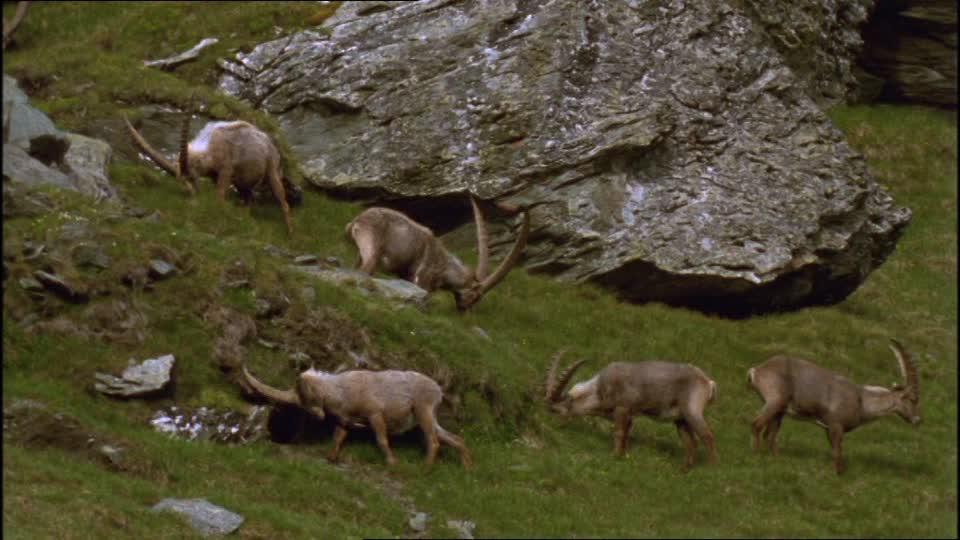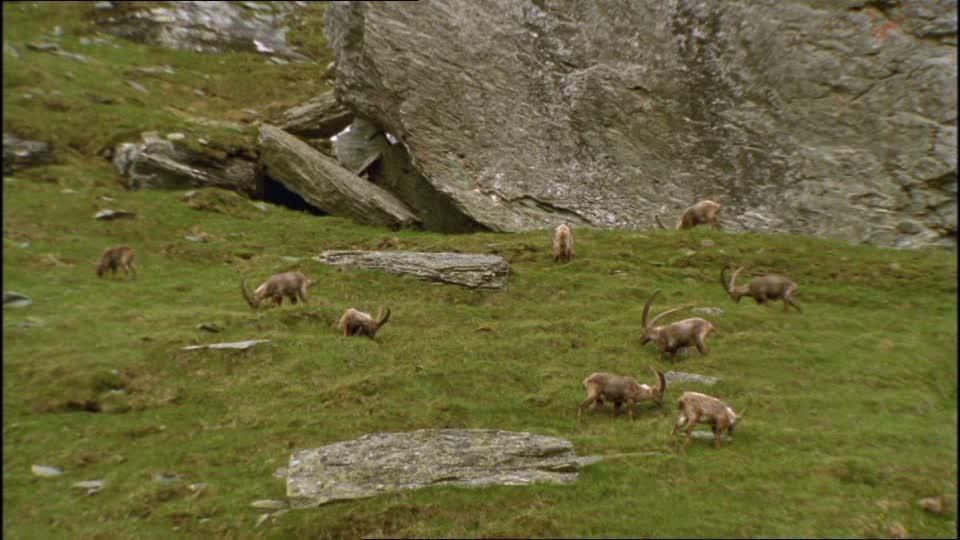The first image is the image on the left, the second image is the image on the right. Assess this claim about the two images: "An image shows a single horned animal in a non-standing position.". Correct or not? Answer yes or no. No. The first image is the image on the left, the second image is the image on the right. Examine the images to the left and right. Is the description "A single horned animal is in a grassy area in one of the images." accurate? Answer yes or no. No. 